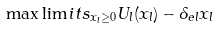<formula> <loc_0><loc_0><loc_500><loc_500>\max \lim i t s _ { x _ { l } \geq 0 } U _ { l } ( x _ { l } ) - \delta _ { e l } x _ { l }</formula> 